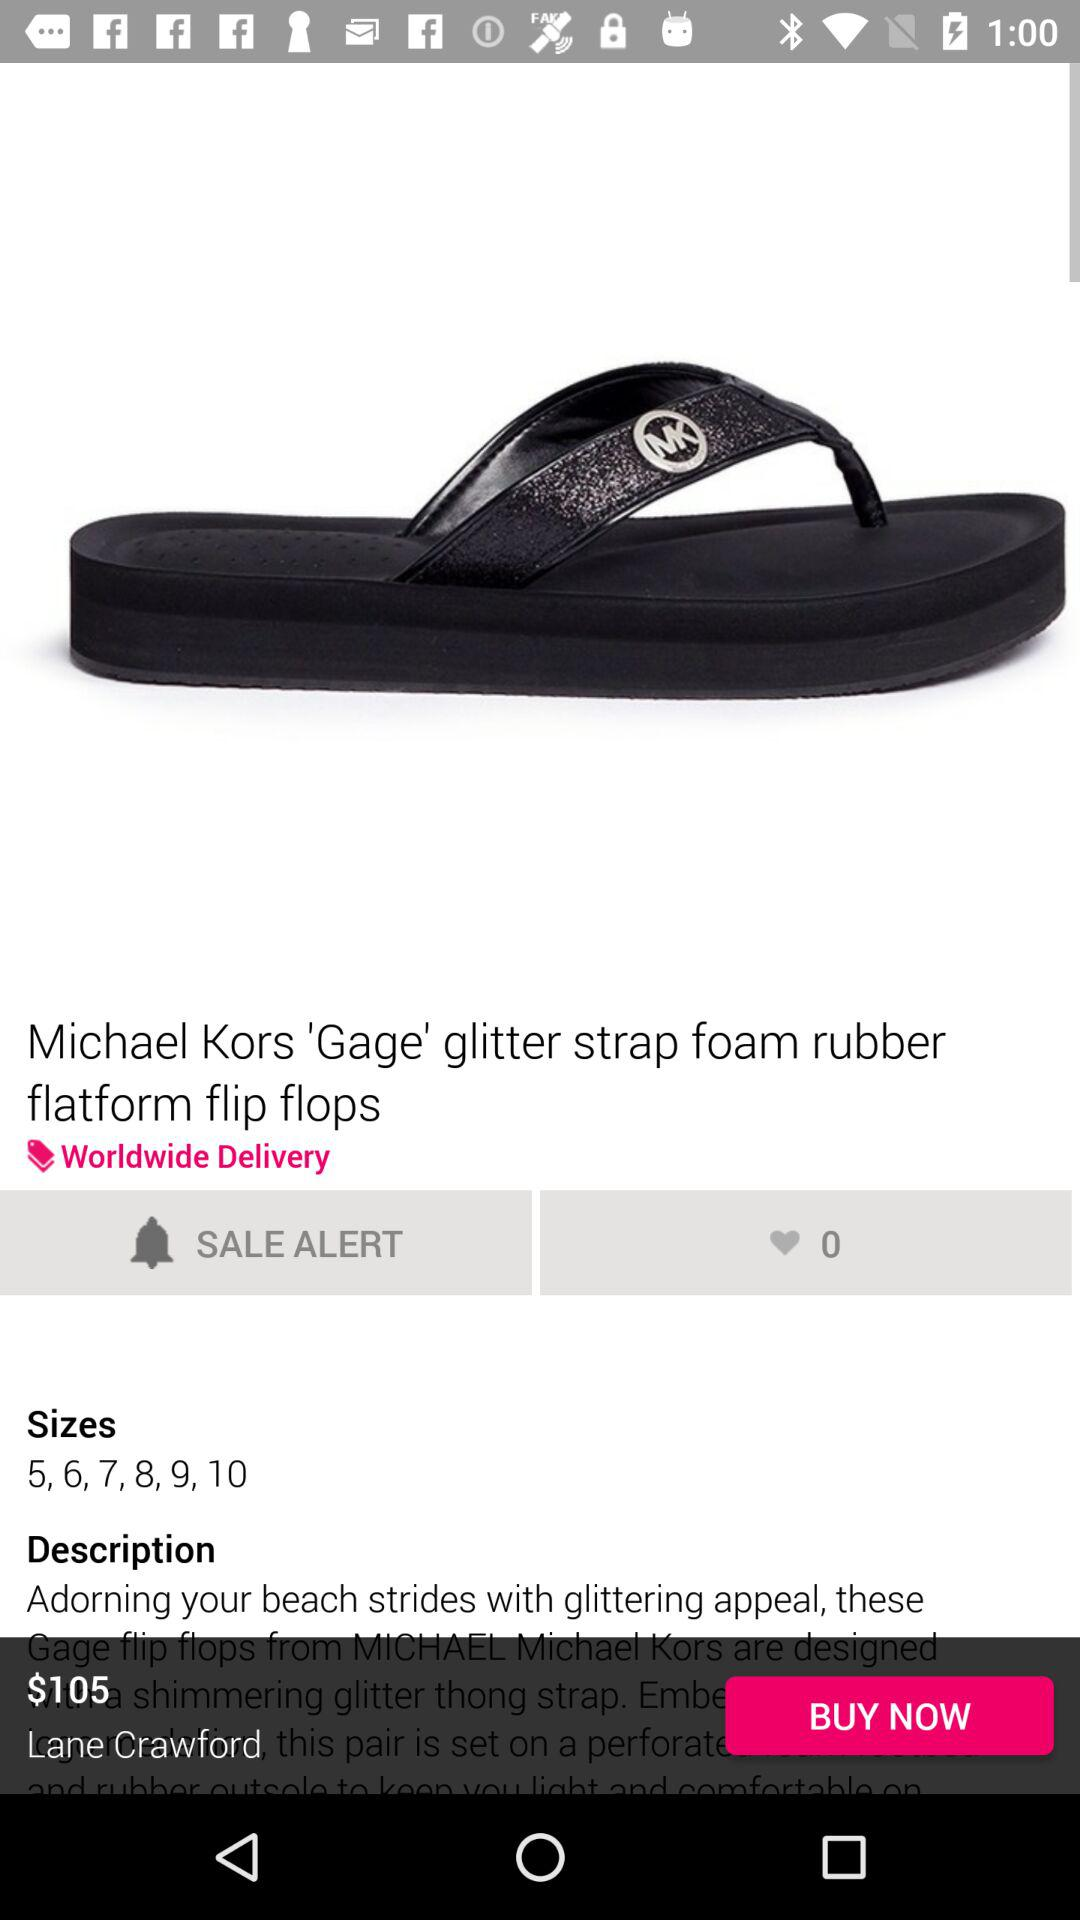How many likes on "Michael Kors 'Gage' glitter strap foam rubber platform flip flops"? There are 0 likes. 